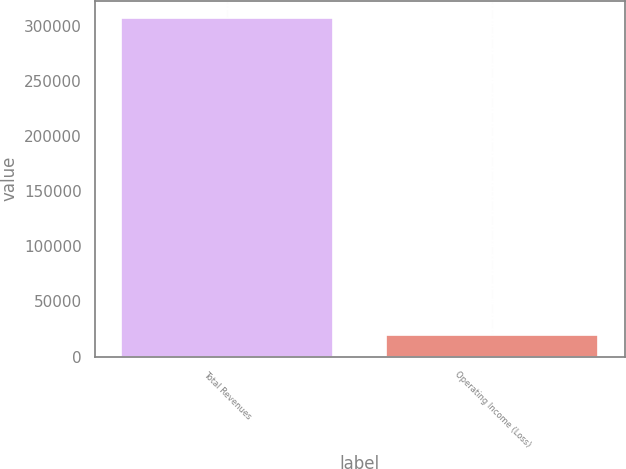<chart> <loc_0><loc_0><loc_500><loc_500><bar_chart><fcel>Total Revenues<fcel>Operating Income (Loss)<nl><fcel>307139<fcel>19664<nl></chart> 